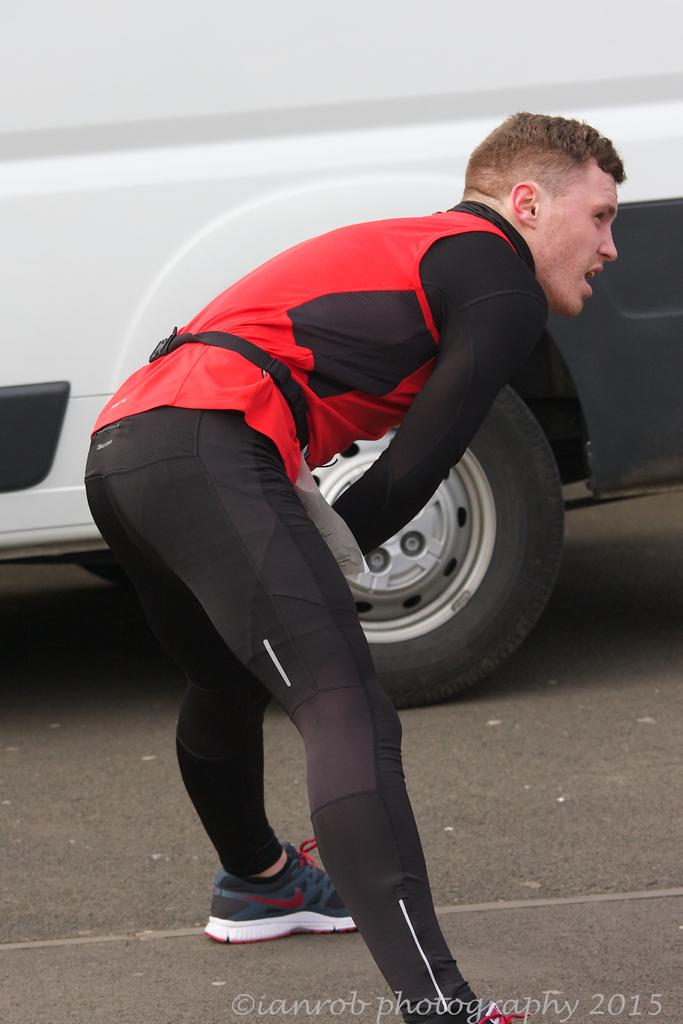Who is present in the image? There is a man in the image. What is the man doing in the image? The man is standing on the road and bending. What else can be seen in the image besides the man? There is a white vehicle in the image. Where is the vehicle located in relation to the man? The vehicle is beside the man. What type of ring can be seen on the man's finger in the image? There is no ring visible on the man's finger in the image. What is the man using to rake leaves in the image? There is no rake present in the image, and the man is not performing any activity related to raking leaves. 